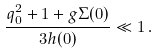<formula> <loc_0><loc_0><loc_500><loc_500>\frac { q _ { 0 } ^ { 2 } + 1 + g \Sigma ( 0 ) } { 3 h ( 0 ) } \ll 1 \, .</formula> 